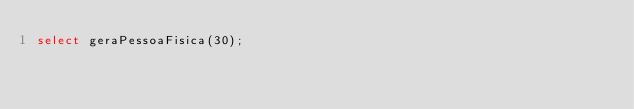Convert code to text. <code><loc_0><loc_0><loc_500><loc_500><_SQL_>select geraPessoaFisica(30);
</code> 